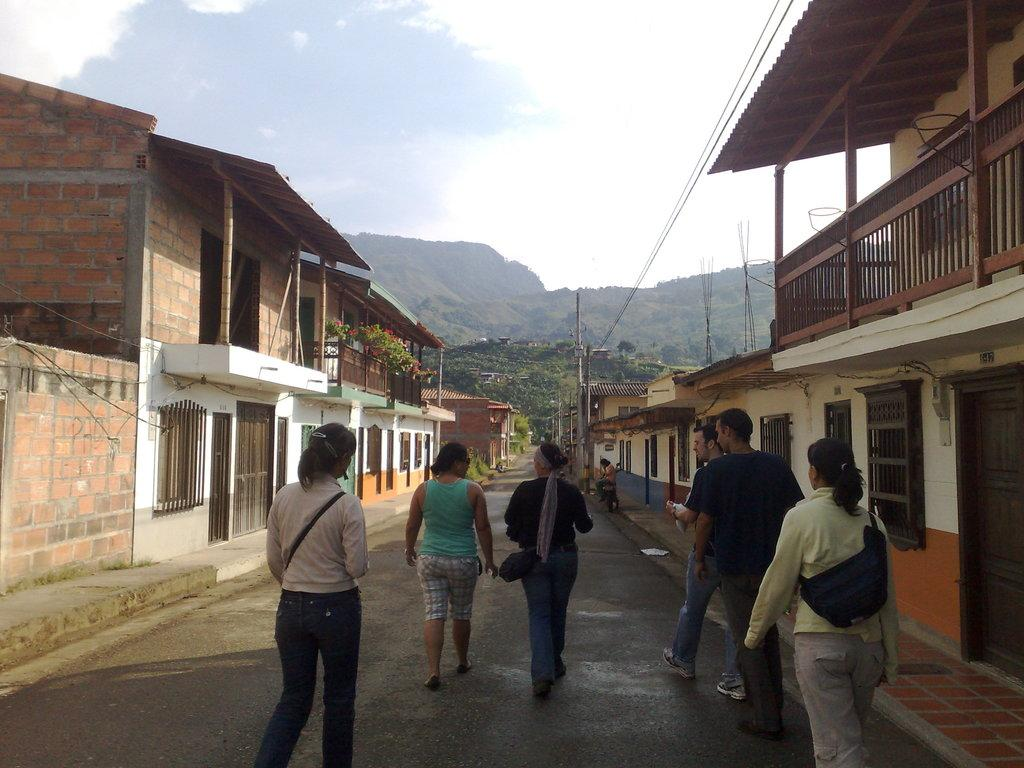What can be seen on the road in the image? There are persons on the road in the image. What type of structures are present in the image? There are houses in the image. What other elements can be seen in the image besides structures? There are plants and poles in the image. What natural feature is visible in the image? There is a mountain in the image. What is visible in the background of the image? The sky is visible in the background of the image. How many gold apples are being held by the persons in the image? There is no mention of gold apples or any apples in the image; it features persons on the road, houses, plants, poles, a mountain, and the sky. What nation is depicted in the image? The image does not depict a specific nation; it shows a road, houses, plants, poles, a mountain, and the sky, which can be found in various countries and regions. 